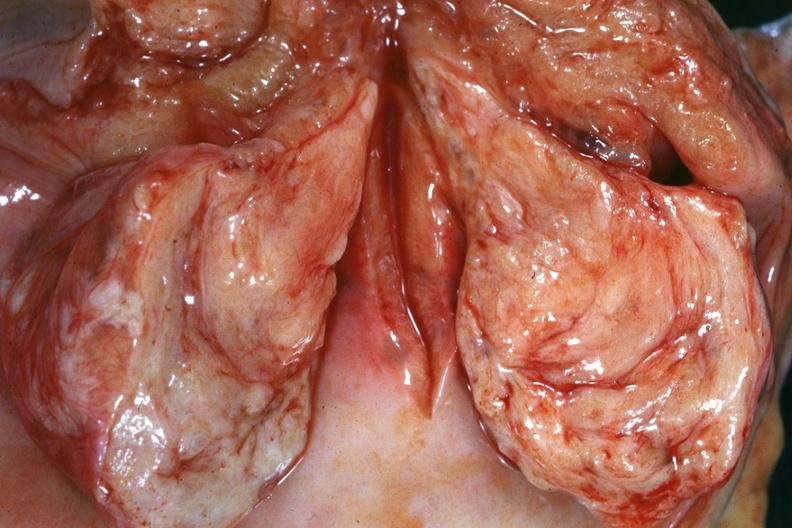s female reproductive present?
Answer the question using a single word or phrase. Yes 